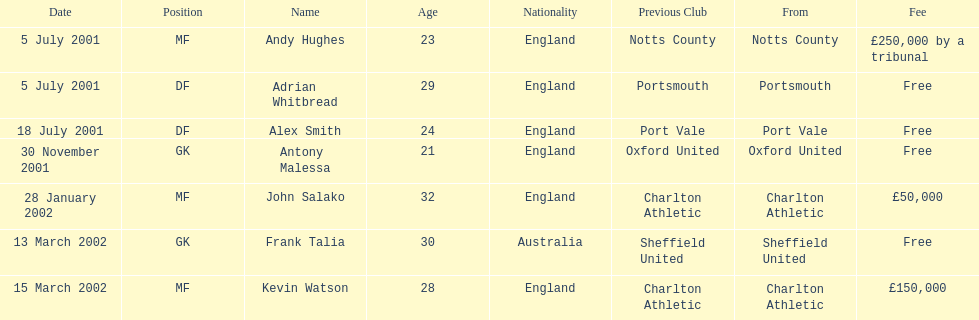What was the transfer fee to transfer kevin watson? £150,000. 